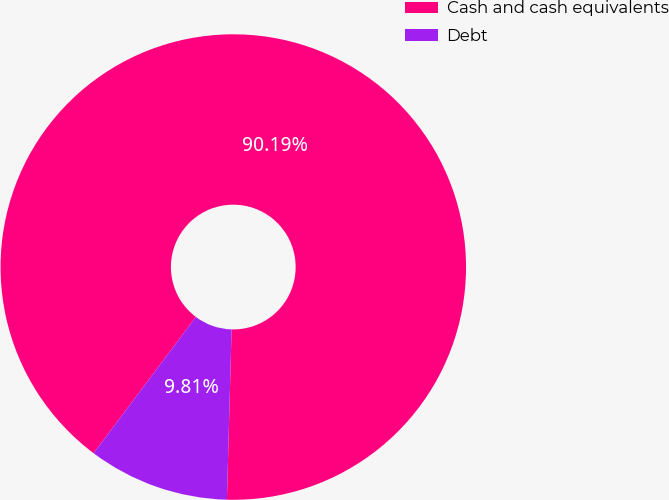Convert chart to OTSL. <chart><loc_0><loc_0><loc_500><loc_500><pie_chart><fcel>Cash and cash equivalents<fcel>Debt<nl><fcel>90.19%<fcel>9.81%<nl></chart> 